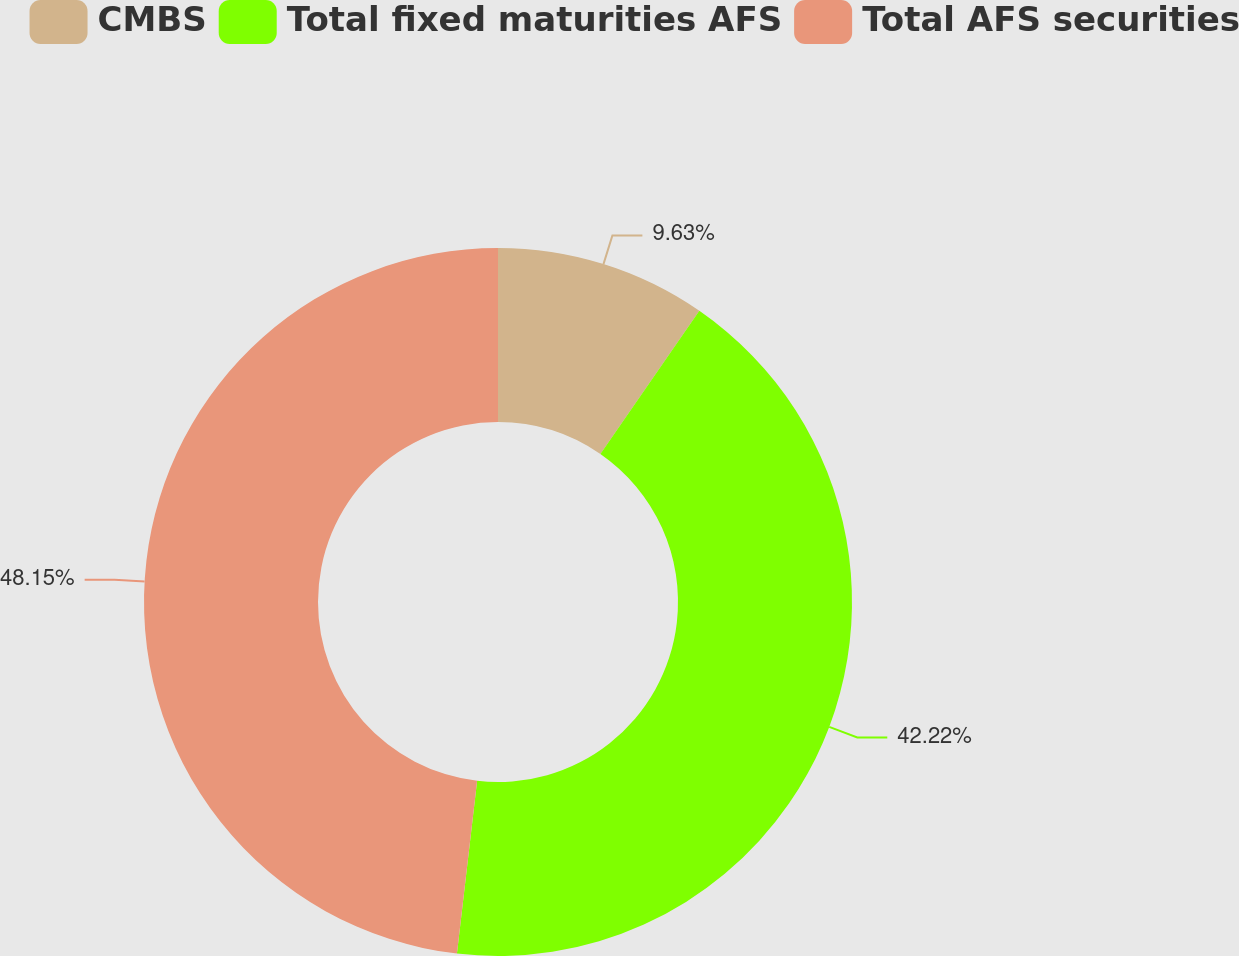Convert chart to OTSL. <chart><loc_0><loc_0><loc_500><loc_500><pie_chart><fcel>CMBS<fcel>Total fixed maturities AFS<fcel>Total AFS securities<nl><fcel>9.63%<fcel>42.22%<fcel>48.15%<nl></chart> 